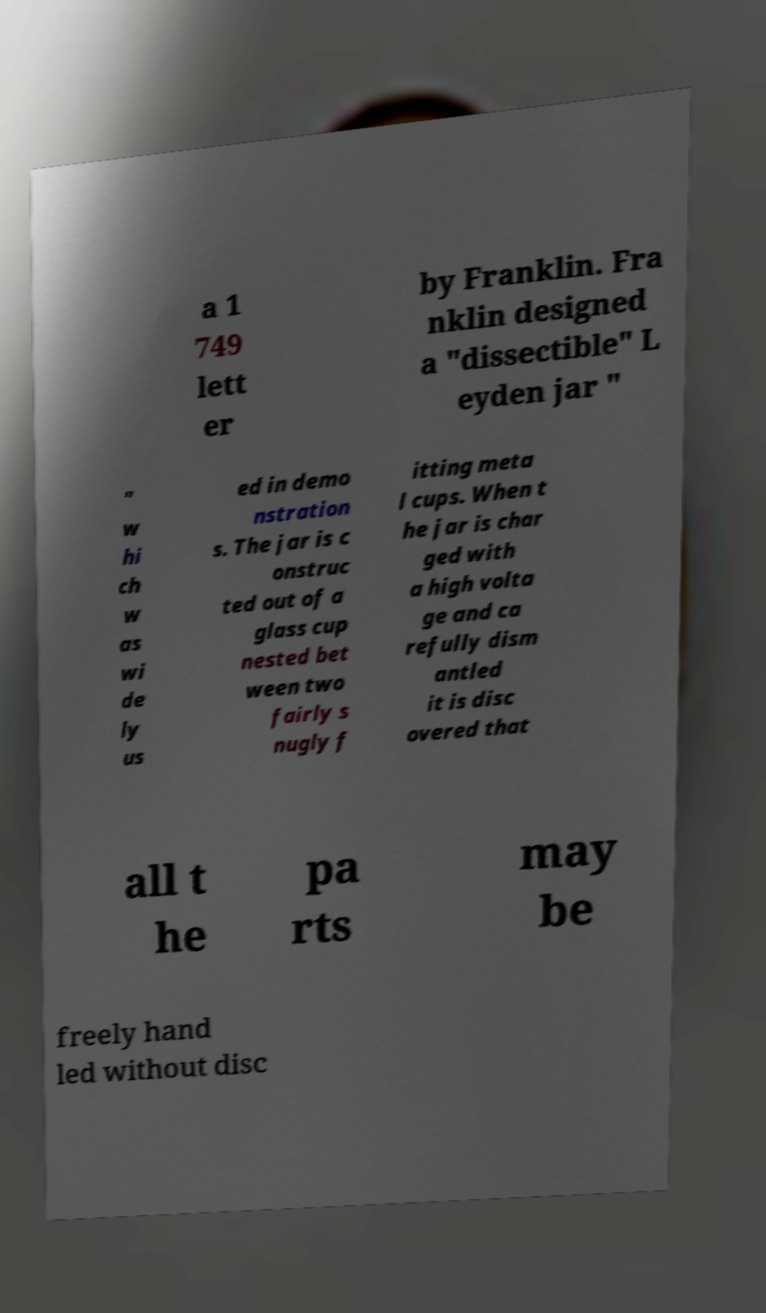Can you accurately transcribe the text from the provided image for me? a 1 749 lett er by Franklin. Fra nklin designed a "dissectible" L eyden jar " " w hi ch w as wi de ly us ed in demo nstration s. The jar is c onstruc ted out of a glass cup nested bet ween two fairly s nugly f itting meta l cups. When t he jar is char ged with a high volta ge and ca refully dism antled it is disc overed that all t he pa rts may be freely hand led without disc 